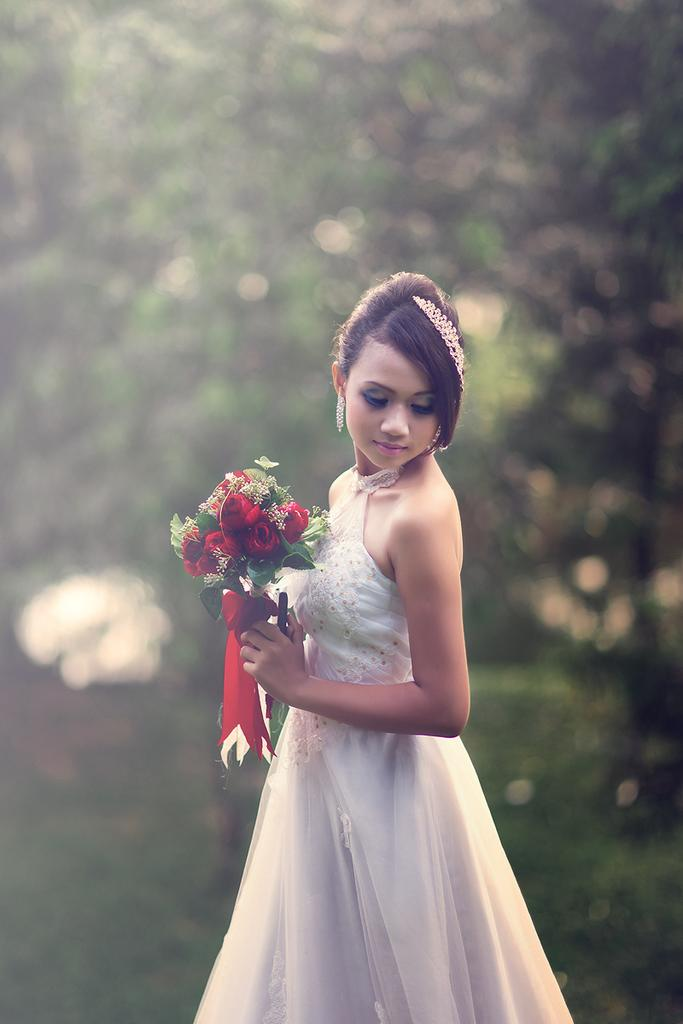Who is the main subject in the image? There is a woman in the image. What is the woman holding in the image? The woman is holding a flower bouquet. What is the woman's posture in the image? The woman is standing in the image. What is the woman wearing in the image? The woman is wearing a white frock in the image. How would you describe the background of the image? The background of the image appears green and is blurred. What type of art can be seen on the bridge in the image? There is no bridge or art present in the image; it features a woman holding a flower bouquet with a green, blurred background. 